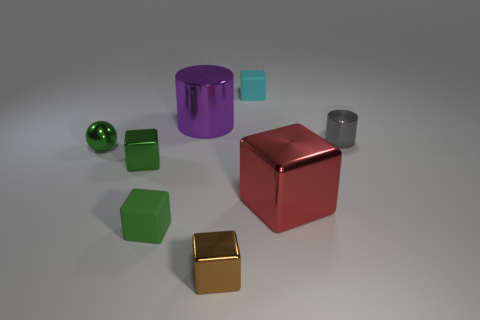How many brown blocks are the same size as the green metal cube?
Ensure brevity in your answer.  1. What number of shiny things are balls or tiny cylinders?
Your response must be concise. 2. What is the size of the metallic object that is the same color as the metallic ball?
Provide a succinct answer. Small. There is a tiny cyan object on the right side of the tiny object on the left side of the tiny green metal cube; what is it made of?
Ensure brevity in your answer.  Rubber. How many objects are either big gray balls or shiny objects that are in front of the tiny gray thing?
Keep it short and to the point. 4. There is a brown thing that is made of the same material as the large block; what is its size?
Provide a succinct answer. Small. What number of gray things are large cylinders or metallic cylinders?
Provide a succinct answer. 1. The metal thing that is the same color as the sphere is what shape?
Give a very brief answer. Cube. Do the green object to the left of the green metallic block and the large object that is in front of the gray thing have the same shape?
Your answer should be very brief. No. How many metallic objects are there?
Keep it short and to the point. 6. 